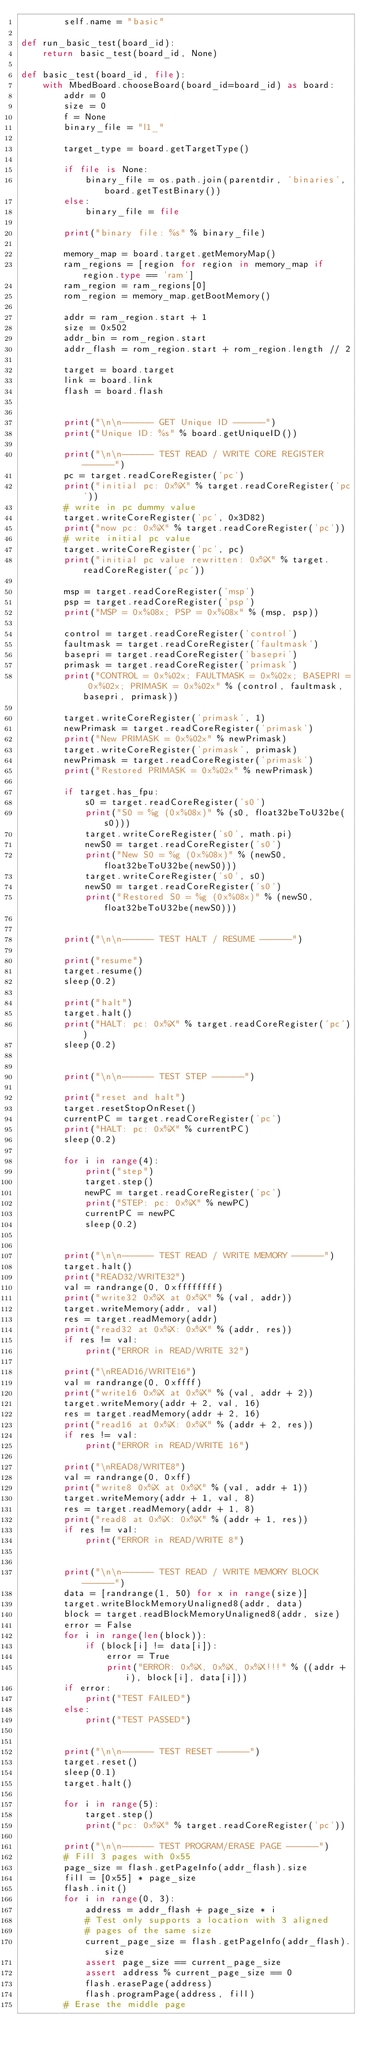Convert code to text. <code><loc_0><loc_0><loc_500><loc_500><_Python_>        self.name = "basic"
    
def run_basic_test(board_id):
    return basic_test(board_id, None)

def basic_test(board_id, file):
    with MbedBoard.chooseBoard(board_id=board_id) as board:
        addr = 0
        size = 0
        f = None
        binary_file = "l1_"

        target_type = board.getTargetType()

        if file is None:
            binary_file = os.path.join(parentdir, 'binaries', board.getTestBinary())
        else:
            binary_file = file

        print("binary file: %s" % binary_file)

        memory_map = board.target.getMemoryMap()
        ram_regions = [region for region in memory_map if region.type == 'ram']
        ram_region = ram_regions[0]
        rom_region = memory_map.getBootMemory()

        addr = ram_region.start + 1
        size = 0x502
        addr_bin = rom_region.start
        addr_flash = rom_region.start + rom_region.length // 2

        target = board.target
        link = board.link
        flash = board.flash


        print("\n\n------ GET Unique ID ------")
        print("Unique ID: %s" % board.getUniqueID())

        print("\n\n------ TEST READ / WRITE CORE REGISTER ------")
        pc = target.readCoreRegister('pc')
        print("initial pc: 0x%X" % target.readCoreRegister('pc'))
        # write in pc dummy value
        target.writeCoreRegister('pc', 0x3D82)
        print("now pc: 0x%X" % target.readCoreRegister('pc'))
        # write initial pc value
        target.writeCoreRegister('pc', pc)
        print("initial pc value rewritten: 0x%X" % target.readCoreRegister('pc'))

        msp = target.readCoreRegister('msp')
        psp = target.readCoreRegister('psp')
        print("MSP = 0x%08x; PSP = 0x%08x" % (msp, psp))

        control = target.readCoreRegister('control')
        faultmask = target.readCoreRegister('faultmask')
        basepri = target.readCoreRegister('basepri')
        primask = target.readCoreRegister('primask')
        print("CONTROL = 0x%02x; FAULTMASK = 0x%02x; BASEPRI = 0x%02x; PRIMASK = 0x%02x" % (control, faultmask, basepri, primask))

        target.writeCoreRegister('primask', 1)
        newPrimask = target.readCoreRegister('primask')
        print("New PRIMASK = 0x%02x" % newPrimask)
        target.writeCoreRegister('primask', primask)
        newPrimask = target.readCoreRegister('primask')
        print("Restored PRIMASK = 0x%02x" % newPrimask)

        if target.has_fpu:
            s0 = target.readCoreRegister('s0')
            print("S0 = %g (0x%08x)" % (s0, float32beToU32be(s0)))
            target.writeCoreRegister('s0', math.pi)
            newS0 = target.readCoreRegister('s0')
            print("New S0 = %g (0x%08x)" % (newS0, float32beToU32be(newS0)))
            target.writeCoreRegister('s0', s0)
            newS0 = target.readCoreRegister('s0')
            print("Restored S0 = %g (0x%08x)" % (newS0, float32beToU32be(newS0)))


        print("\n\n------ TEST HALT / RESUME ------")

        print("resume")
        target.resume()
        sleep(0.2)

        print("halt")
        target.halt()
        print("HALT: pc: 0x%X" % target.readCoreRegister('pc'))
        sleep(0.2)


        print("\n\n------ TEST STEP ------")

        print("reset and halt")
        target.resetStopOnReset()
        currentPC = target.readCoreRegister('pc')
        print("HALT: pc: 0x%X" % currentPC)
        sleep(0.2)

        for i in range(4):
            print("step")
            target.step()
            newPC = target.readCoreRegister('pc')
            print("STEP: pc: 0x%X" % newPC)
            currentPC = newPC
            sleep(0.2)


        print("\n\n------ TEST READ / WRITE MEMORY ------")
        target.halt()
        print("READ32/WRITE32")
        val = randrange(0, 0xffffffff)
        print("write32 0x%X at 0x%X" % (val, addr))
        target.writeMemory(addr, val)
        res = target.readMemory(addr)
        print("read32 at 0x%X: 0x%X" % (addr, res))
        if res != val:
            print("ERROR in READ/WRITE 32")

        print("\nREAD16/WRITE16")
        val = randrange(0, 0xffff)
        print("write16 0x%X at 0x%X" % (val, addr + 2))
        target.writeMemory(addr + 2, val, 16)
        res = target.readMemory(addr + 2, 16)
        print("read16 at 0x%X: 0x%X" % (addr + 2, res))
        if res != val:
            print("ERROR in READ/WRITE 16")

        print("\nREAD8/WRITE8")
        val = randrange(0, 0xff)
        print("write8 0x%X at 0x%X" % (val, addr + 1))
        target.writeMemory(addr + 1, val, 8)
        res = target.readMemory(addr + 1, 8)
        print("read8 at 0x%X: 0x%X" % (addr + 1, res))
        if res != val:
            print("ERROR in READ/WRITE 8")


        print("\n\n------ TEST READ / WRITE MEMORY BLOCK ------")
        data = [randrange(1, 50) for x in range(size)]
        target.writeBlockMemoryUnaligned8(addr, data)
        block = target.readBlockMemoryUnaligned8(addr, size)
        error = False
        for i in range(len(block)):
            if (block[i] != data[i]):
                error = True
                print("ERROR: 0x%X, 0x%X, 0x%X!!!" % ((addr + i), block[i], data[i]))
        if error:
            print("TEST FAILED")
        else:
            print("TEST PASSED")


        print("\n\n------ TEST RESET ------")
        target.reset()
        sleep(0.1)
        target.halt()

        for i in range(5):
            target.step()
            print("pc: 0x%X" % target.readCoreRegister('pc'))

        print("\n\n------ TEST PROGRAM/ERASE PAGE ------")
        # Fill 3 pages with 0x55
        page_size = flash.getPageInfo(addr_flash).size
        fill = [0x55] * page_size
        flash.init()
        for i in range(0, 3):
            address = addr_flash + page_size * i
            # Test only supports a location with 3 aligned
            # pages of the same size
            current_page_size = flash.getPageInfo(addr_flash).size
            assert page_size == current_page_size
            assert address % current_page_size == 0
            flash.erasePage(address)
            flash.programPage(address, fill)
        # Erase the middle page</code> 